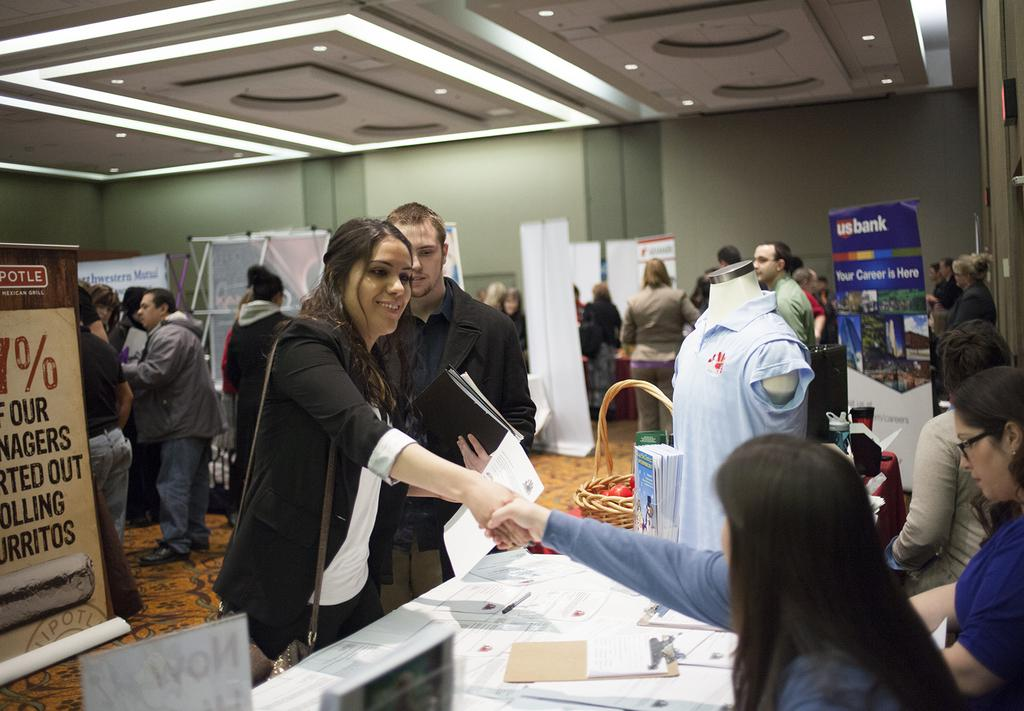<image>
Provide a brief description of the given image. A blue sign for USbank sits to the the right of the room. 